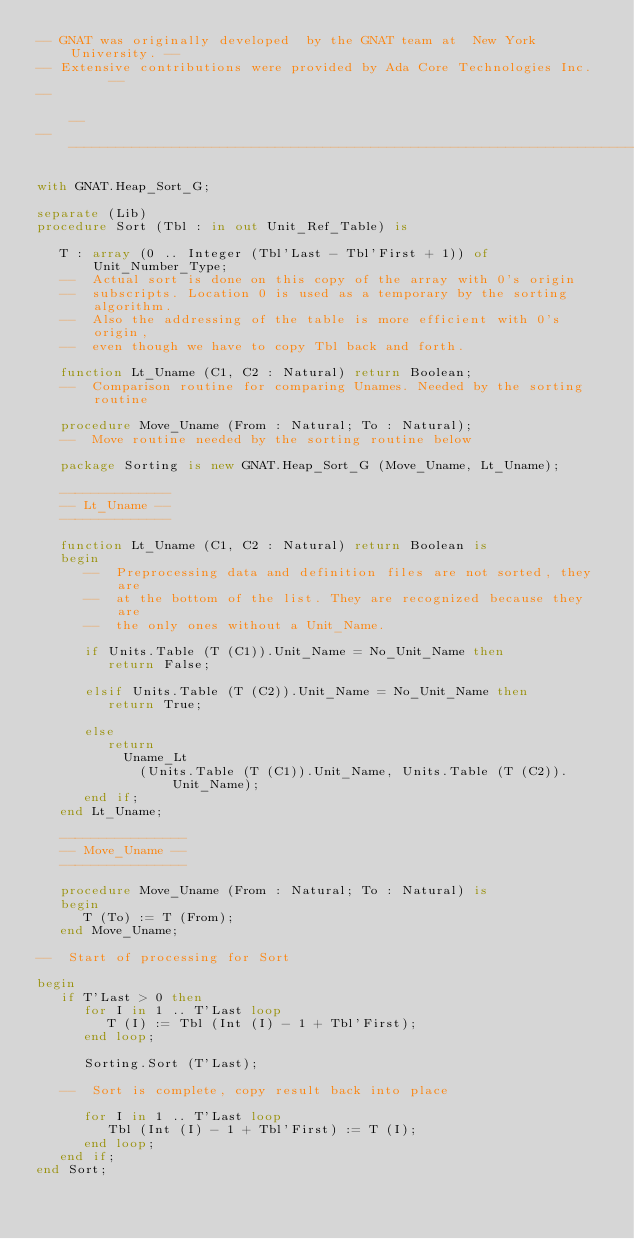Convert code to text. <code><loc_0><loc_0><loc_500><loc_500><_Ada_>-- GNAT was originally developed  by the GNAT team at  New York University. --
-- Extensive contributions were provided by Ada Core Technologies Inc.      --
--                                                                          --
------------------------------------------------------------------------------

with GNAT.Heap_Sort_G;

separate (Lib)
procedure Sort (Tbl : in out Unit_Ref_Table) is

   T : array (0 .. Integer (Tbl'Last - Tbl'First + 1)) of Unit_Number_Type;
   --  Actual sort is done on this copy of the array with 0's origin
   --  subscripts. Location 0 is used as a temporary by the sorting algorithm.
   --  Also the addressing of the table is more efficient with 0's origin,
   --  even though we have to copy Tbl back and forth.

   function Lt_Uname (C1, C2 : Natural) return Boolean;
   --  Comparison routine for comparing Unames. Needed by the sorting routine

   procedure Move_Uname (From : Natural; To : Natural);
   --  Move routine needed by the sorting routine below

   package Sorting is new GNAT.Heap_Sort_G (Move_Uname, Lt_Uname);

   --------------
   -- Lt_Uname --
   --------------

   function Lt_Uname (C1, C2 : Natural) return Boolean is
   begin
      --  Preprocessing data and definition files are not sorted, they are
      --  at the bottom of the list. They are recognized because they are
      --  the only ones without a Unit_Name.

      if Units.Table (T (C1)).Unit_Name = No_Unit_Name then
         return False;

      elsif Units.Table (T (C2)).Unit_Name = No_Unit_Name then
         return True;

      else
         return
           Uname_Lt
             (Units.Table (T (C1)).Unit_Name, Units.Table (T (C2)).Unit_Name);
      end if;
   end Lt_Uname;

   ----------------
   -- Move_Uname --
   ----------------

   procedure Move_Uname (From : Natural; To : Natural) is
   begin
      T (To) := T (From);
   end Move_Uname;

--  Start of processing for Sort

begin
   if T'Last > 0 then
      for I in 1 .. T'Last loop
         T (I) := Tbl (Int (I) - 1 + Tbl'First);
      end loop;

      Sorting.Sort (T'Last);

   --  Sort is complete, copy result back into place

      for I in 1 .. T'Last loop
         Tbl (Int (I) - 1 + Tbl'First) := T (I);
      end loop;
   end if;
end Sort;
</code> 